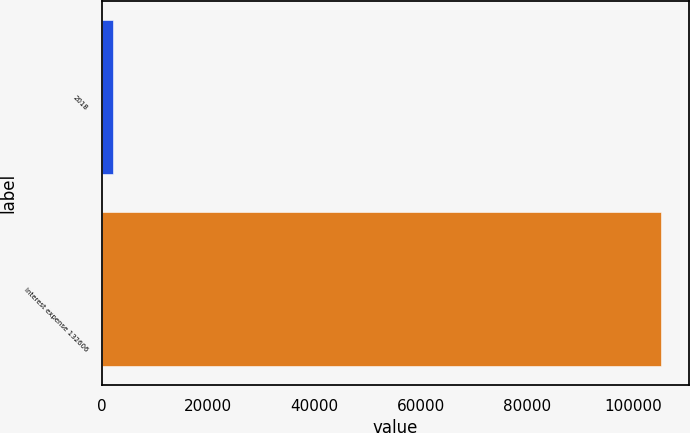<chart> <loc_0><loc_0><loc_500><loc_500><bar_chart><fcel>2018<fcel>Interest expense 132606<nl><fcel>2017<fcel>105237<nl></chart> 